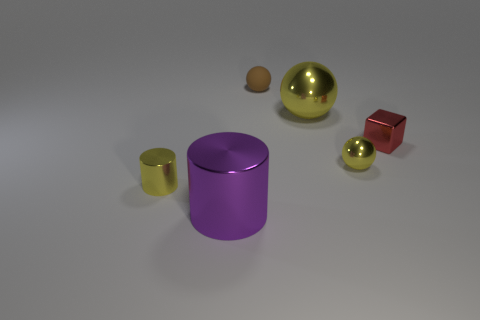Subtract 1 balls. How many balls are left? 2 Subtract all small balls. How many balls are left? 1 Add 1 small yellow metallic balls. How many objects exist? 7 Subtract all cylinders. How many objects are left? 4 Subtract 0 gray balls. How many objects are left? 6 Subtract all big yellow balls. Subtract all small yellow shiny objects. How many objects are left? 3 Add 6 large purple metallic cylinders. How many large purple metallic cylinders are left? 7 Add 4 big cyan cylinders. How many big cyan cylinders exist? 4 